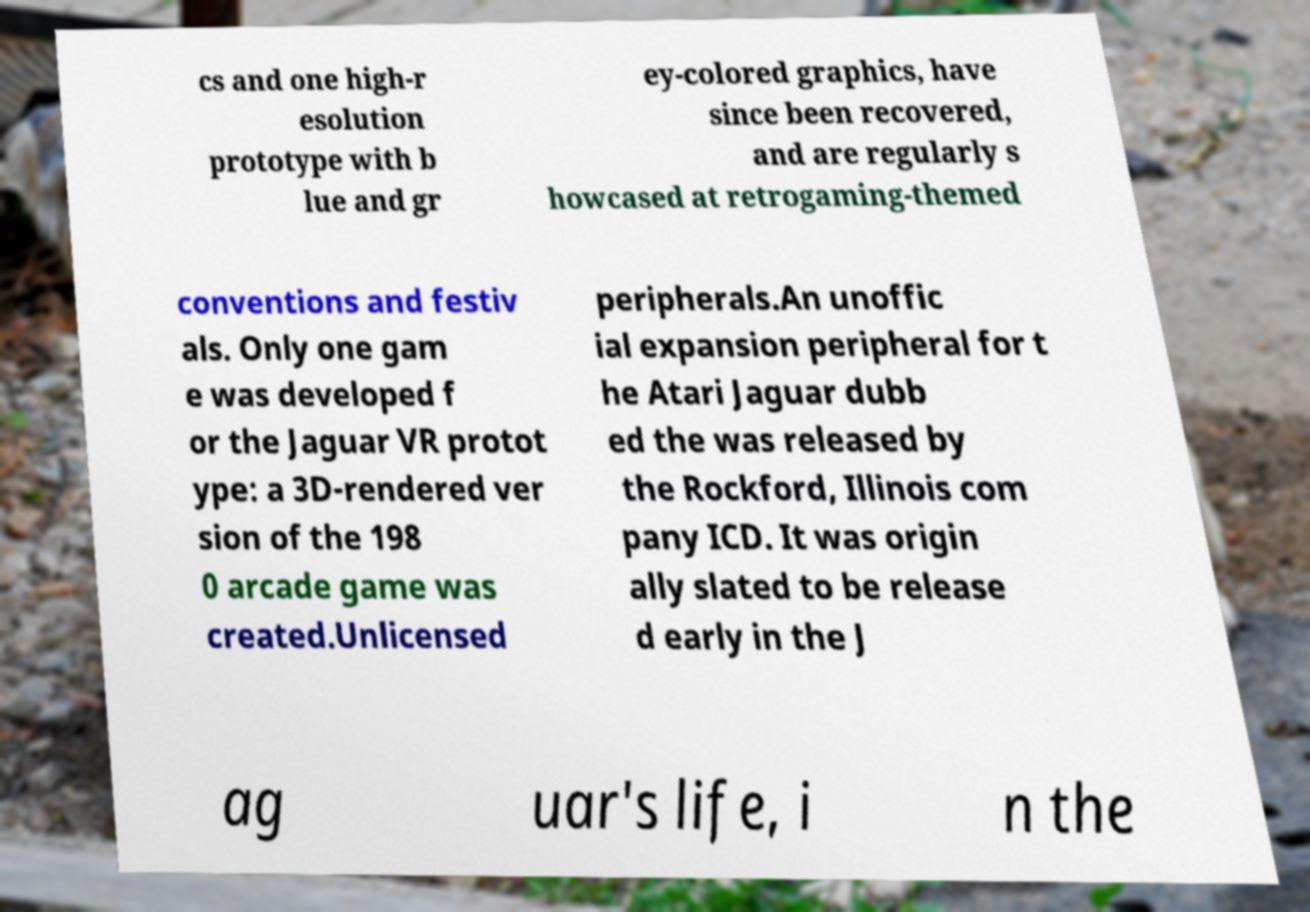There's text embedded in this image that I need extracted. Can you transcribe it verbatim? cs and one high-r esolution prototype with b lue and gr ey-colored graphics, have since been recovered, and are regularly s howcased at retrogaming-themed conventions and festiv als. Only one gam e was developed f or the Jaguar VR protot ype: a 3D-rendered ver sion of the 198 0 arcade game was created.Unlicensed peripherals.An unoffic ial expansion peripheral for t he Atari Jaguar dubb ed the was released by the Rockford, Illinois com pany ICD. It was origin ally slated to be release d early in the J ag uar's life, i n the 